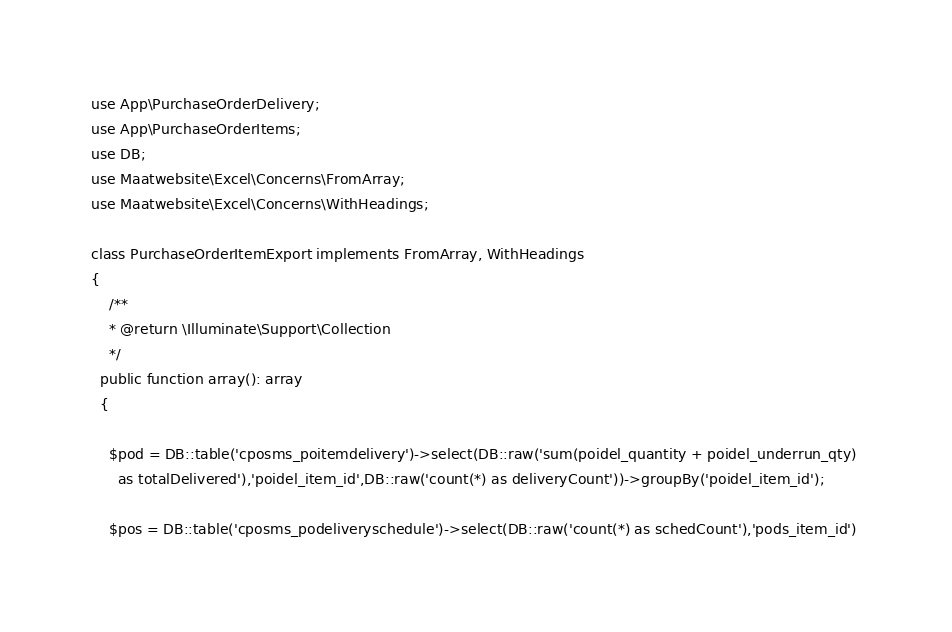Convert code to text. <code><loc_0><loc_0><loc_500><loc_500><_PHP_>
use App\PurchaseOrderDelivery;
use App\PurchaseOrderItems;
use DB;
use Maatwebsite\Excel\Concerns\FromArray;
use Maatwebsite\Excel\Concerns\WithHeadings;

class PurchaseOrderItemExport implements FromArray, WithHeadings
{
    /**
    * @return \Illuminate\Support\Collection
    */
  public function array(): array
  {

  	$pod = DB::table('cposms_poitemdelivery')->select(DB::raw('sum(poidel_quantity + poidel_underrun_qty) 
      as totalDelivered'),'poidel_item_id',DB::raw('count(*) as deliveryCount'))->groupBy('poidel_item_id');

    $pos = DB::table('cposms_podeliveryschedule')->select(DB::raw('count(*) as schedCount'),'pods_item_id')</code> 